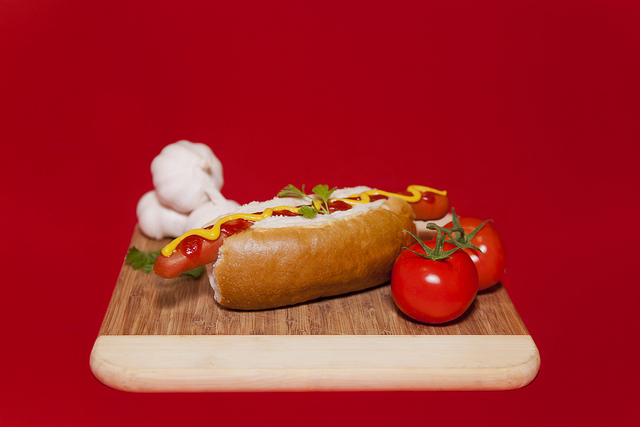<image>What meal is this for? I am not sure what meal this is for. It can be either for lunch or dinner. What meal is this for? I don't know what meal this is for. It can be for lunch or dinner. 